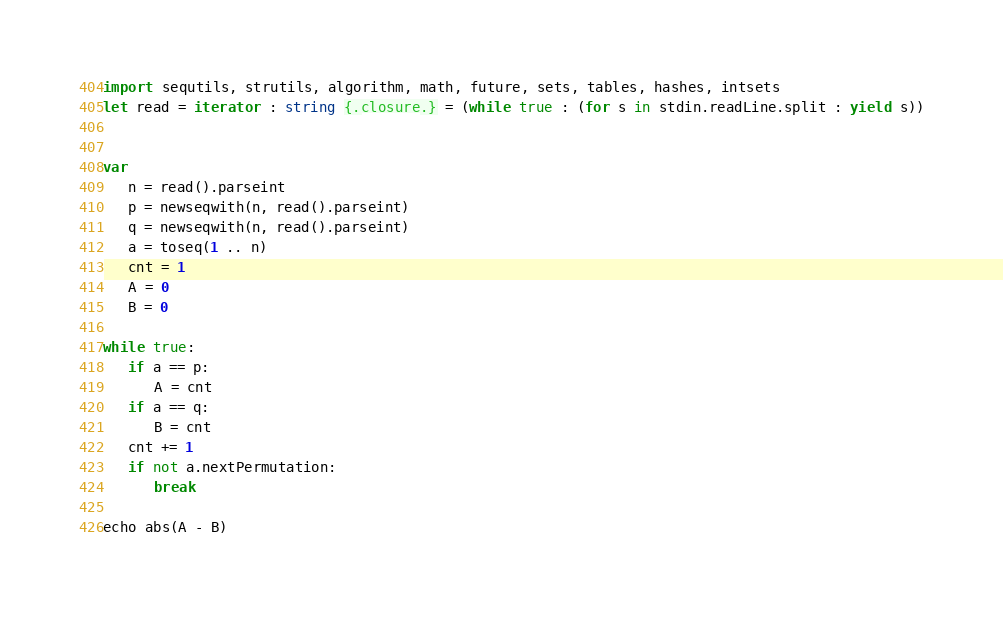<code> <loc_0><loc_0><loc_500><loc_500><_Nim_>import sequtils, strutils, algorithm, math, future, sets, tables, hashes, intsets
let read = iterator : string {.closure.} = (while true : (for s in stdin.readLine.split : yield s))


var
   n = read().parseint
   p = newseqwith(n, read().parseint)
   q = newseqwith(n, read().parseint)
   a = toseq(1 .. n)
   cnt = 1
   A = 0
   B = 0

while true:
   if a == p:
      A = cnt
   if a == q:
      B = cnt
   cnt += 1
   if not a.nextPermutation:
      break

echo abs(A - B)






</code> 